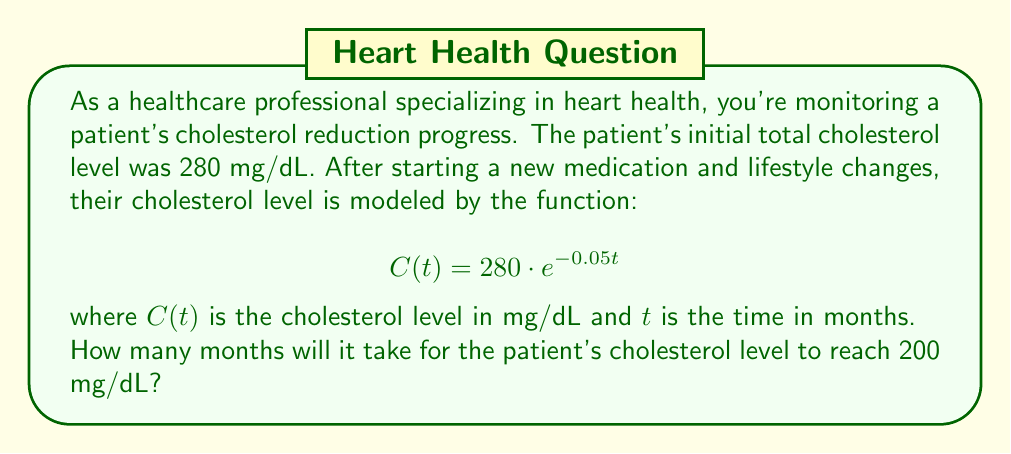Could you help me with this problem? To solve this problem, we need to use the properties of logarithms. Let's approach this step-by-step:

1) We want to find $t$ when $C(t) = 200$. So, we set up the equation:

   $$200 = 280 \cdot e^{-0.05t}$$

2) Divide both sides by 280:

   $$\frac{200}{280} = e^{-0.05t}$$

3) Simplify the left side:

   $$\frac{5}{7} = e^{-0.05t}$$

4) Take the natural logarithm of both sides:

   $$\ln(\frac{5}{7}) = \ln(e^{-0.05t})$$

5) Use the logarithm property $\ln(e^x) = x$:

   $$\ln(\frac{5}{7}) = -0.05t$$

6) Solve for $t$:

   $$t = -\frac{\ln(\frac{5}{7})}{0.05}$$

7) Calculate the value (you can use a calculator for this):

   $$t \approx 6.73$$

8) Since we're dealing with months, we round up to the nearest whole number.
Answer: It will take 7 months for the patient's cholesterol level to reach 200 mg/dL. 